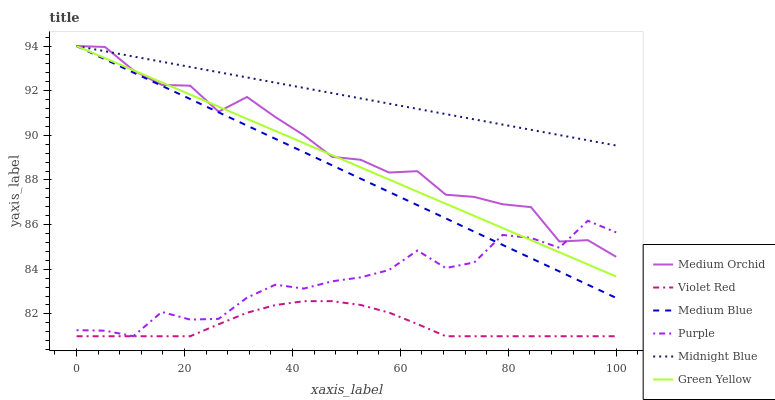Does Violet Red have the minimum area under the curve?
Answer yes or no. Yes. Does Midnight Blue have the maximum area under the curve?
Answer yes or no. Yes. Does Purple have the minimum area under the curve?
Answer yes or no. No. Does Purple have the maximum area under the curve?
Answer yes or no. No. Is Green Yellow the smoothest?
Answer yes or no. Yes. Is Purple the roughest?
Answer yes or no. Yes. Is Midnight Blue the smoothest?
Answer yes or no. No. Is Midnight Blue the roughest?
Answer yes or no. No. Does Violet Red have the lowest value?
Answer yes or no. Yes. Does Purple have the lowest value?
Answer yes or no. No. Does Green Yellow have the highest value?
Answer yes or no. Yes. Does Purple have the highest value?
Answer yes or no. No. Is Purple less than Midnight Blue?
Answer yes or no. Yes. Is Midnight Blue greater than Purple?
Answer yes or no. Yes. Does Green Yellow intersect Medium Blue?
Answer yes or no. Yes. Is Green Yellow less than Medium Blue?
Answer yes or no. No. Is Green Yellow greater than Medium Blue?
Answer yes or no. No. Does Purple intersect Midnight Blue?
Answer yes or no. No. 